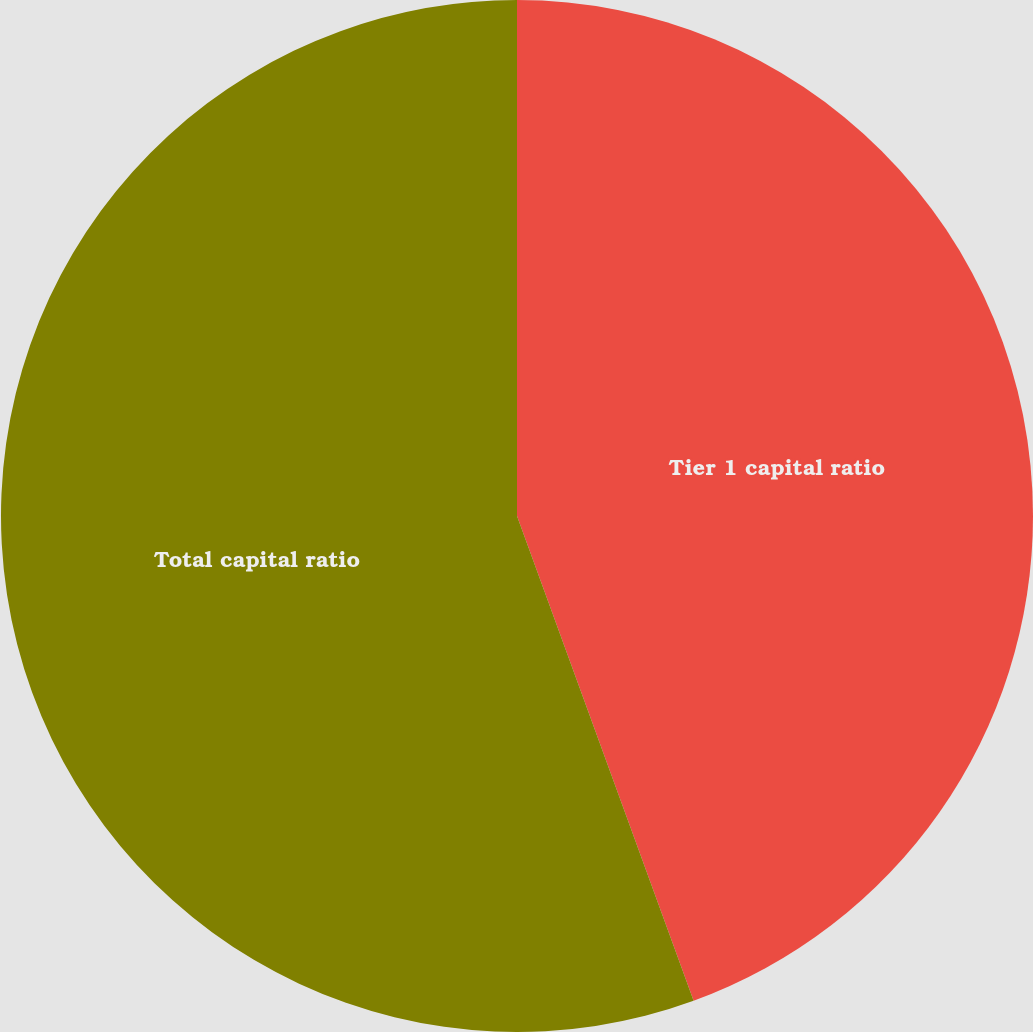Convert chart. <chart><loc_0><loc_0><loc_500><loc_500><pie_chart><fcel>Tier 1 capital ratio<fcel>Total capital ratio<nl><fcel>44.44%<fcel>55.56%<nl></chart> 